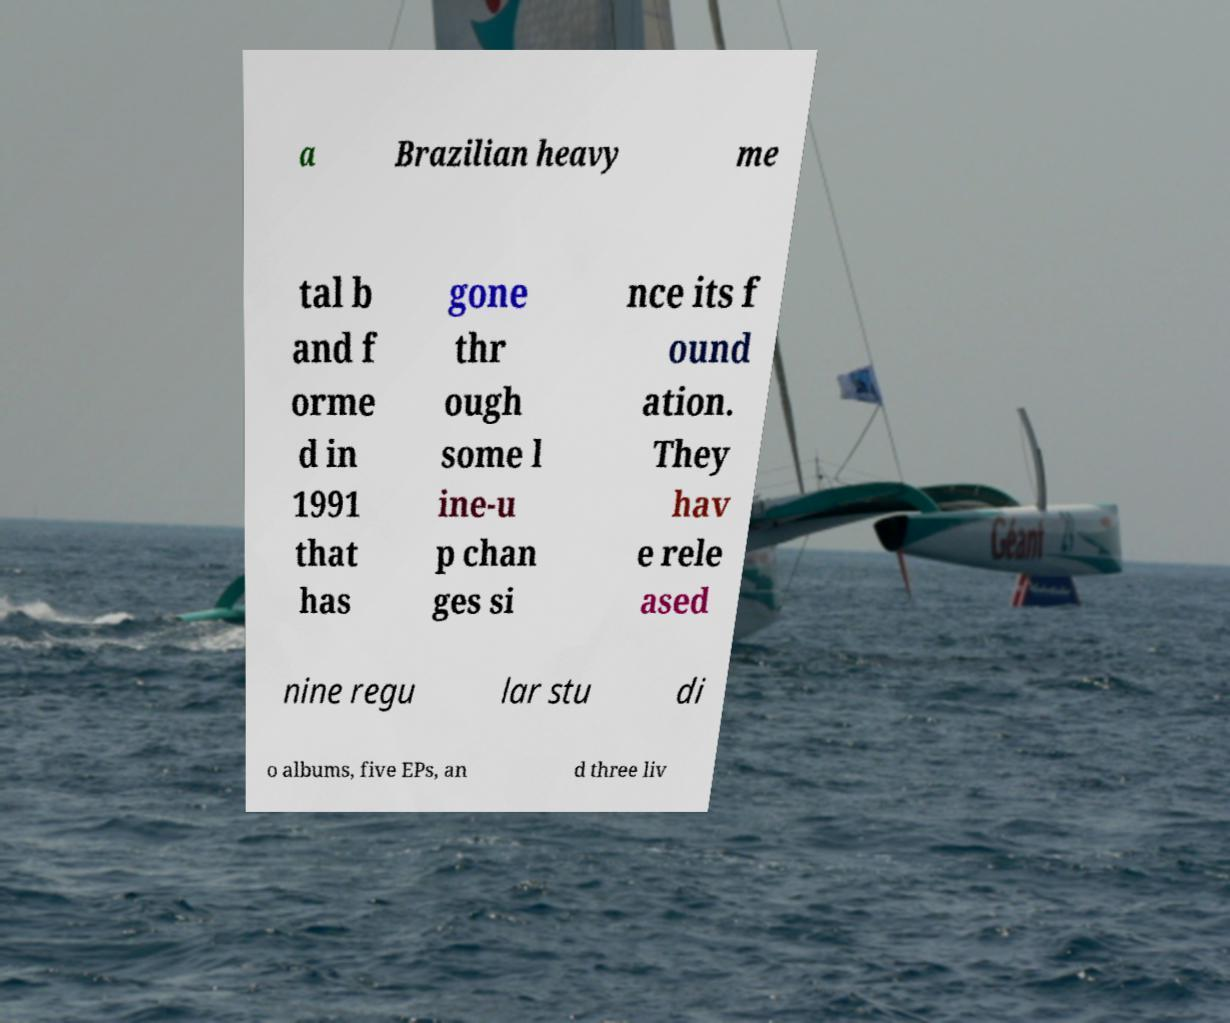Can you accurately transcribe the text from the provided image for me? a Brazilian heavy me tal b and f orme d in 1991 that has gone thr ough some l ine-u p chan ges si nce its f ound ation. They hav e rele ased nine regu lar stu di o albums, five EPs, an d three liv 